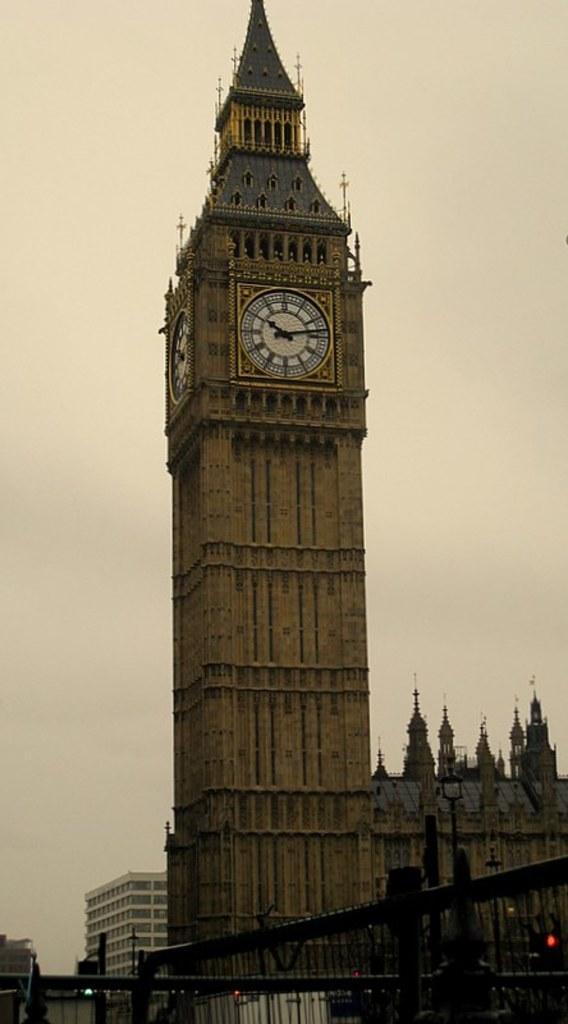How would you summarize this image in a sentence or two? In this image I see a tower on which there are 2 clocks and I see number of buildings and I see the fencing over here. In the background I see the sky. 